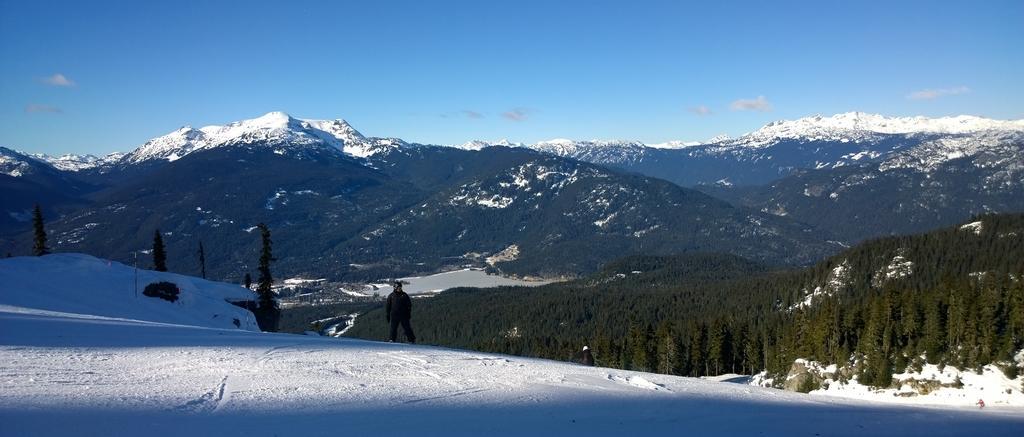Describe this image in one or two sentences. In this image we can see snow, mountains, trees, sky and we can also see a person standing. 